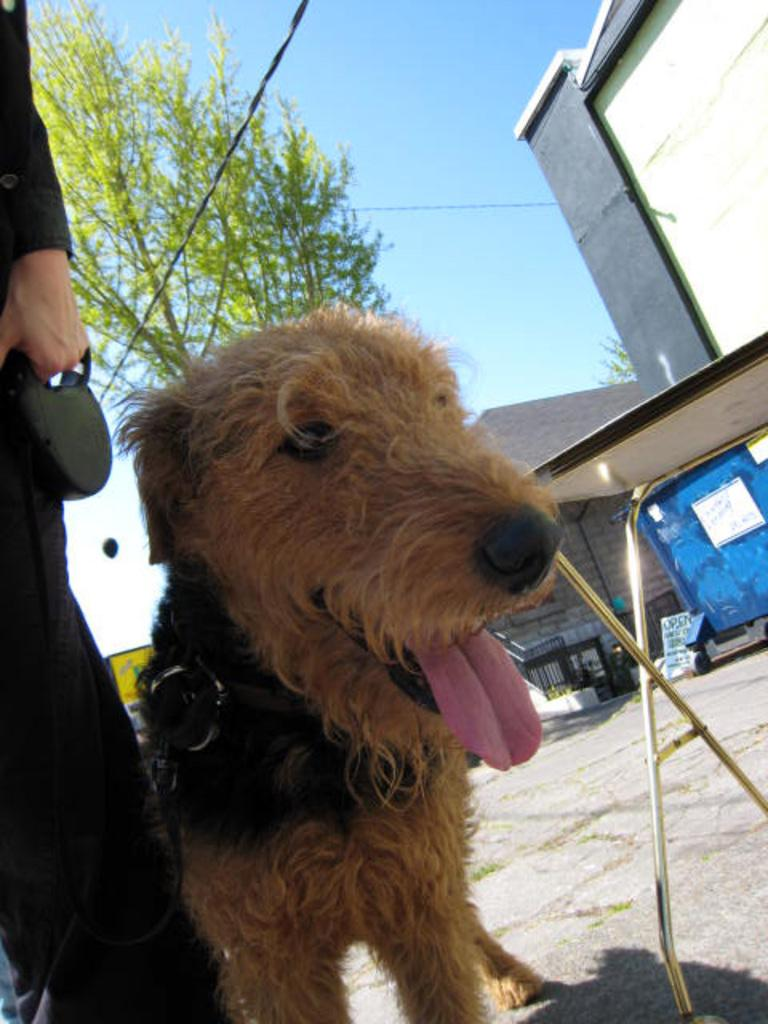What type of animal can be seen in the image? There is a dog in the image. What type of furniture is present in the image? There is a table in the image. What type of structures are visible in the image? There are houses in the image. What type of vegetation is present in the image? There are trees in the image. What type of man-made structures are present in the image? There are wires in the image. What type of human presence is visible in the image? There are people standing in the image. What type of path is visible in the image? The path is visible in the image. What type of natural element is visible in the image? The sky is visible in the image. How many tomatoes are being balanced on the dog's nose in the image? There are no tomatoes present in the image, and the dog is not balancing anything on its nose. What type of lift is visible in the image? There is no lift present in the image. 